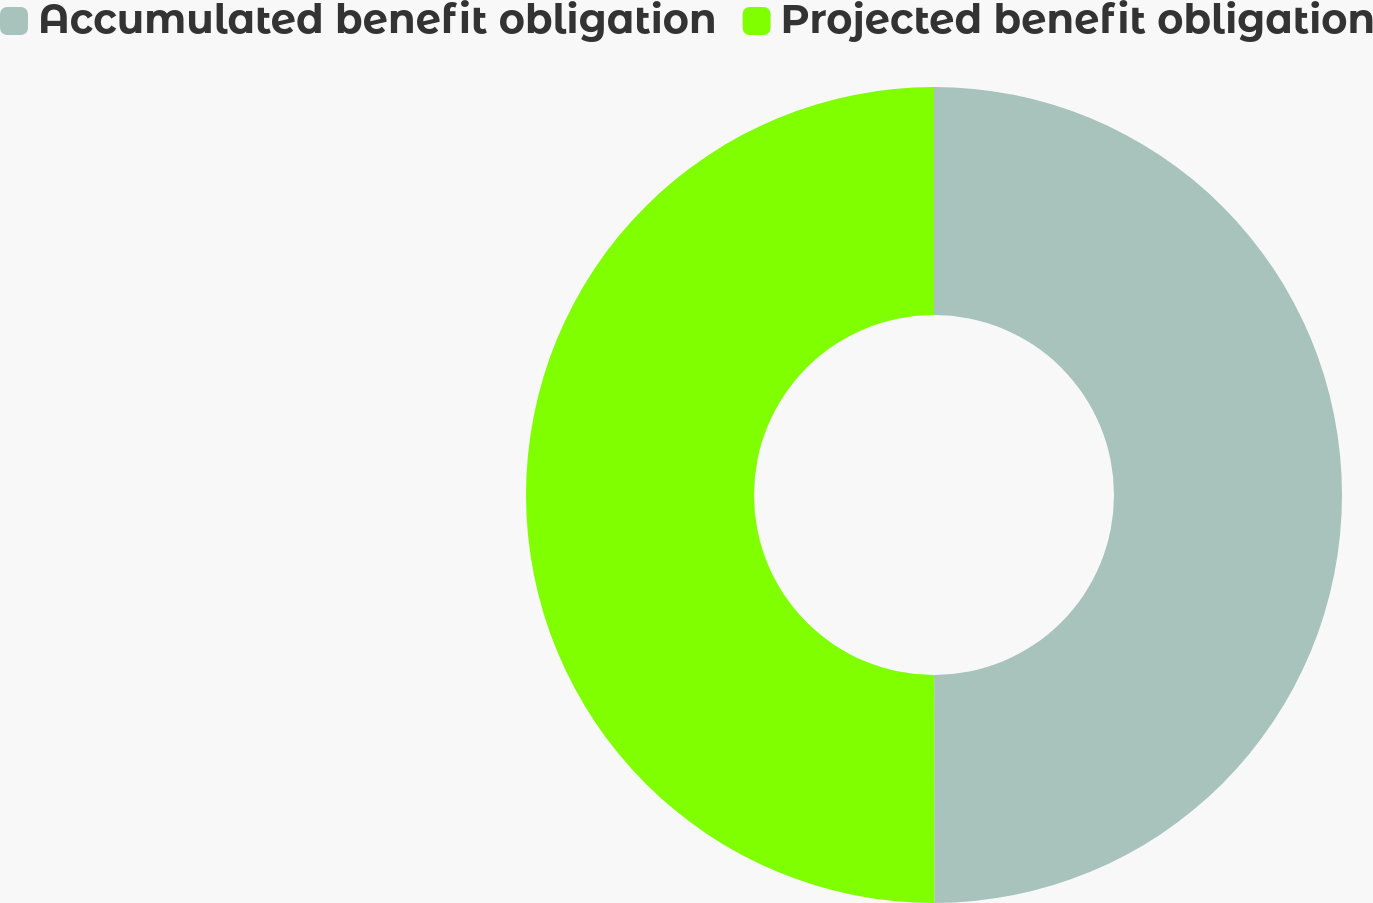Convert chart. <chart><loc_0><loc_0><loc_500><loc_500><pie_chart><fcel>Accumulated benefit obligation<fcel>Projected benefit obligation<nl><fcel>49.99%<fcel>50.01%<nl></chart> 